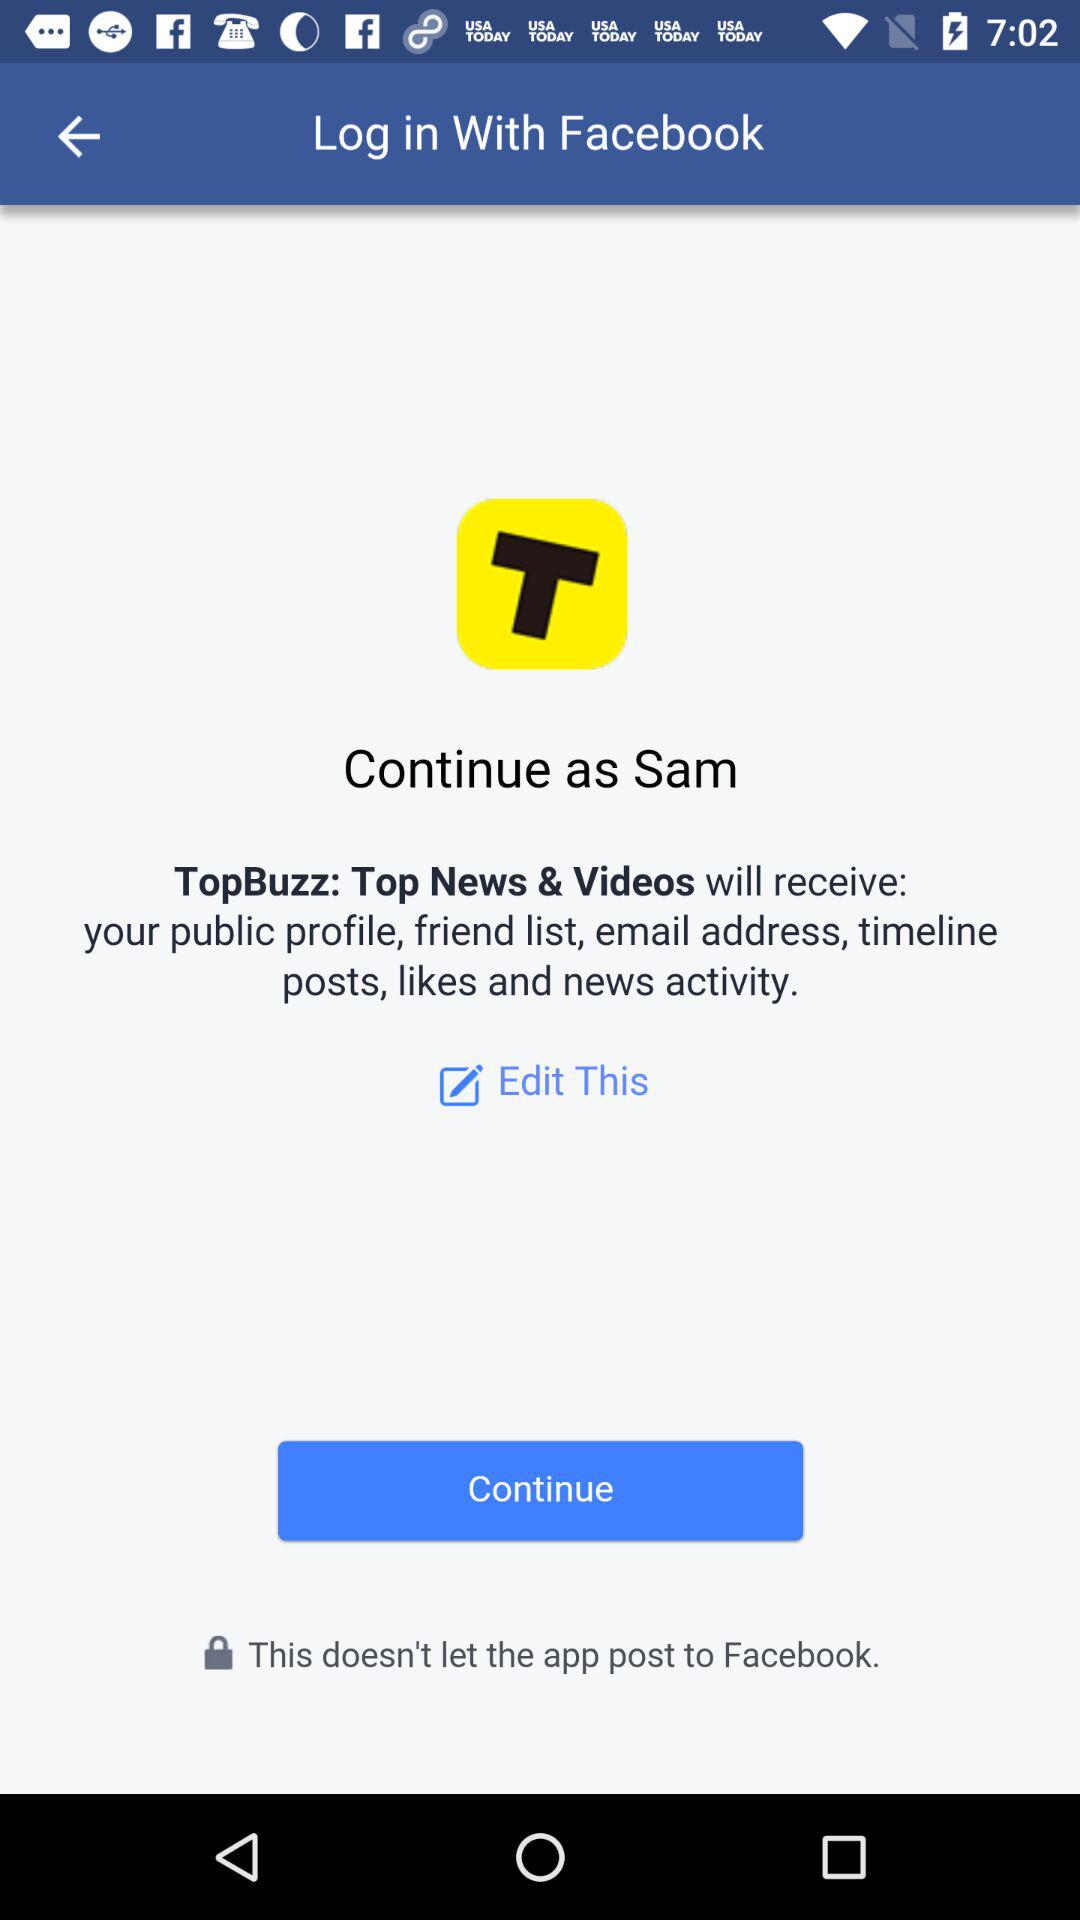What application will receive the public profile, friend list, email address, timeline posts, likes and news activity? The application that will receive the public profile, friend list, email address, timeline posts, likes and news activity is "TopBuzz: Top News & Videos". 